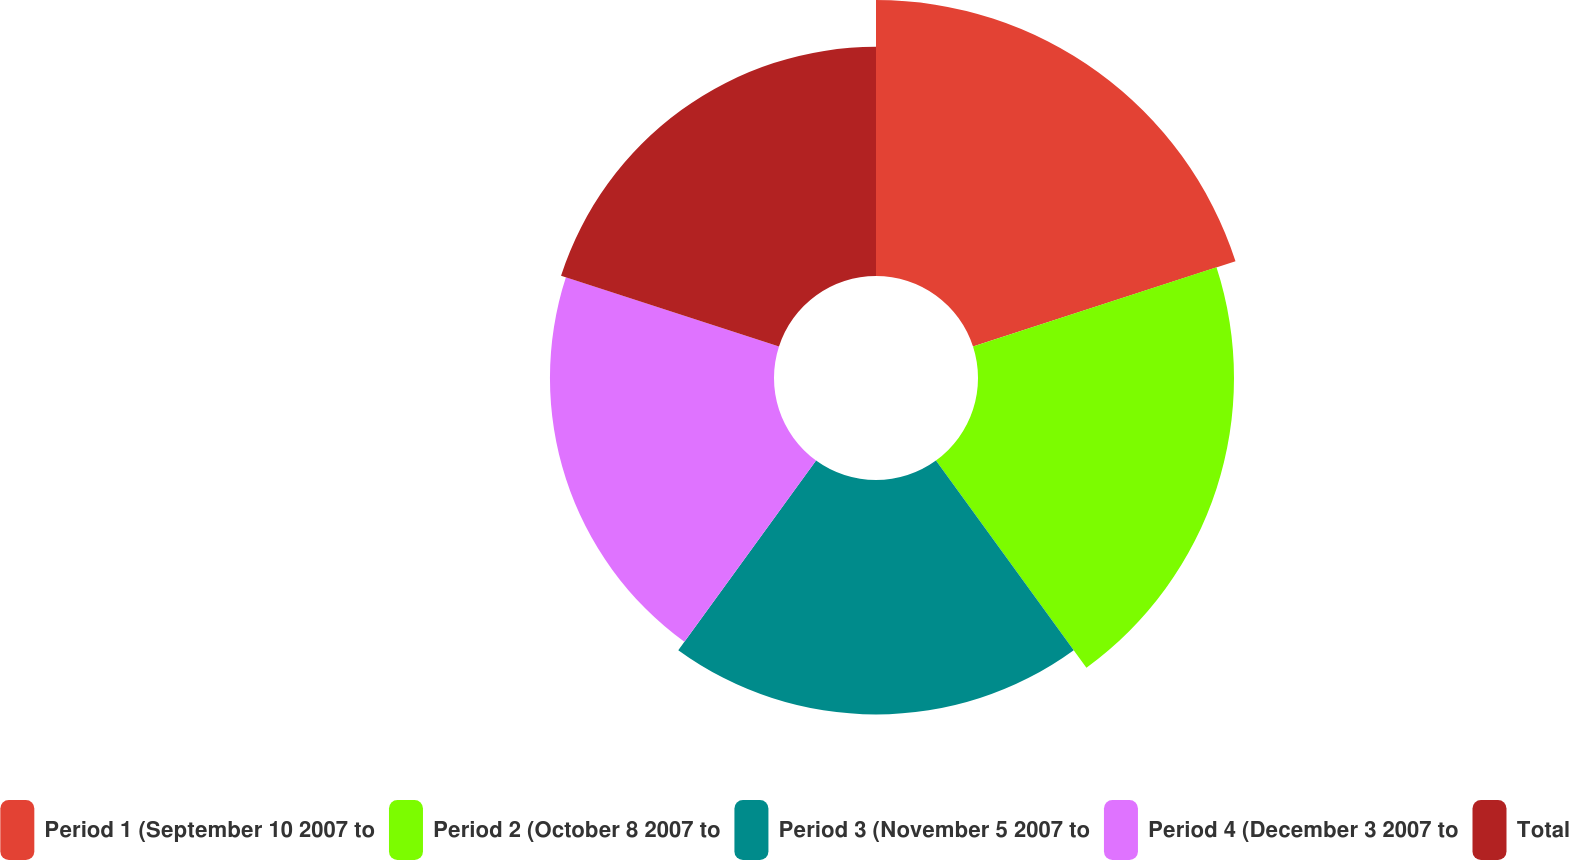<chart> <loc_0><loc_0><loc_500><loc_500><pie_chart><fcel>Period 1 (September 10 2007 to<fcel>Period 2 (October 8 2007 to<fcel>Period 3 (November 5 2007 to<fcel>Period 4 (December 3 2007 to<fcel>Total<nl><fcel>22.63%<fcel>20.99%<fcel>19.22%<fcel>18.37%<fcel>18.79%<nl></chart> 